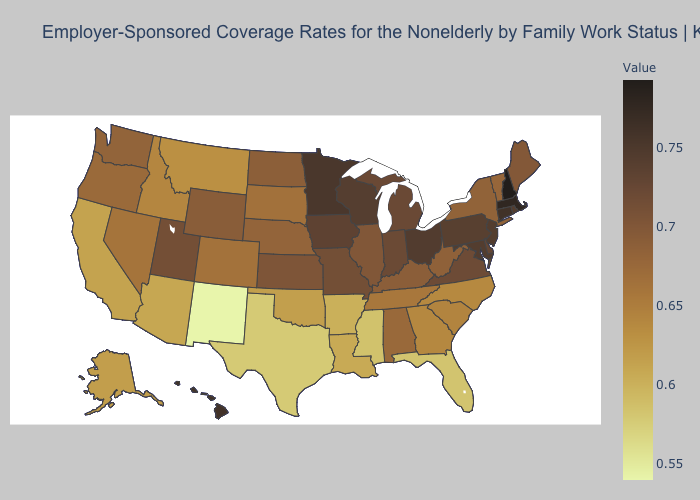Does Texas have a lower value than Maryland?
Concise answer only. Yes. Which states have the lowest value in the USA?
Give a very brief answer. New Mexico. Which states have the lowest value in the USA?
Be succinct. New Mexico. Does New Hampshire have the highest value in the USA?
Keep it brief. Yes. Which states have the lowest value in the Northeast?
Write a very short answer. Vermont. Does Louisiana have the lowest value in the USA?
Give a very brief answer. No. Which states hav the highest value in the South?
Quick response, please. Maryland. 